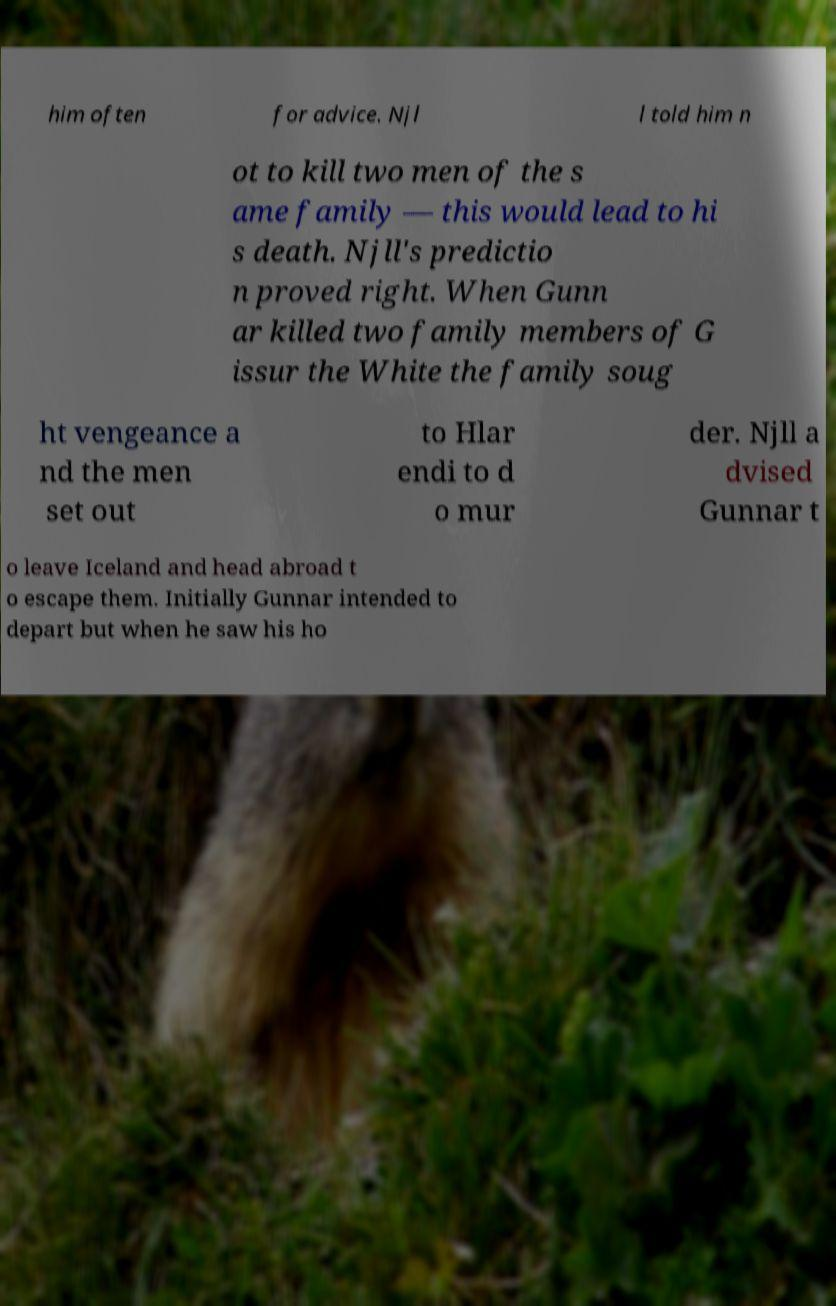Please identify and transcribe the text found in this image. him often for advice. Njl l told him n ot to kill two men of the s ame family — this would lead to hi s death. Njll's predictio n proved right. When Gunn ar killed two family members of G issur the White the family soug ht vengeance a nd the men set out to Hlar endi to d o mur der. Njll a dvised Gunnar t o leave Iceland and head abroad t o escape them. Initially Gunnar intended to depart but when he saw his ho 